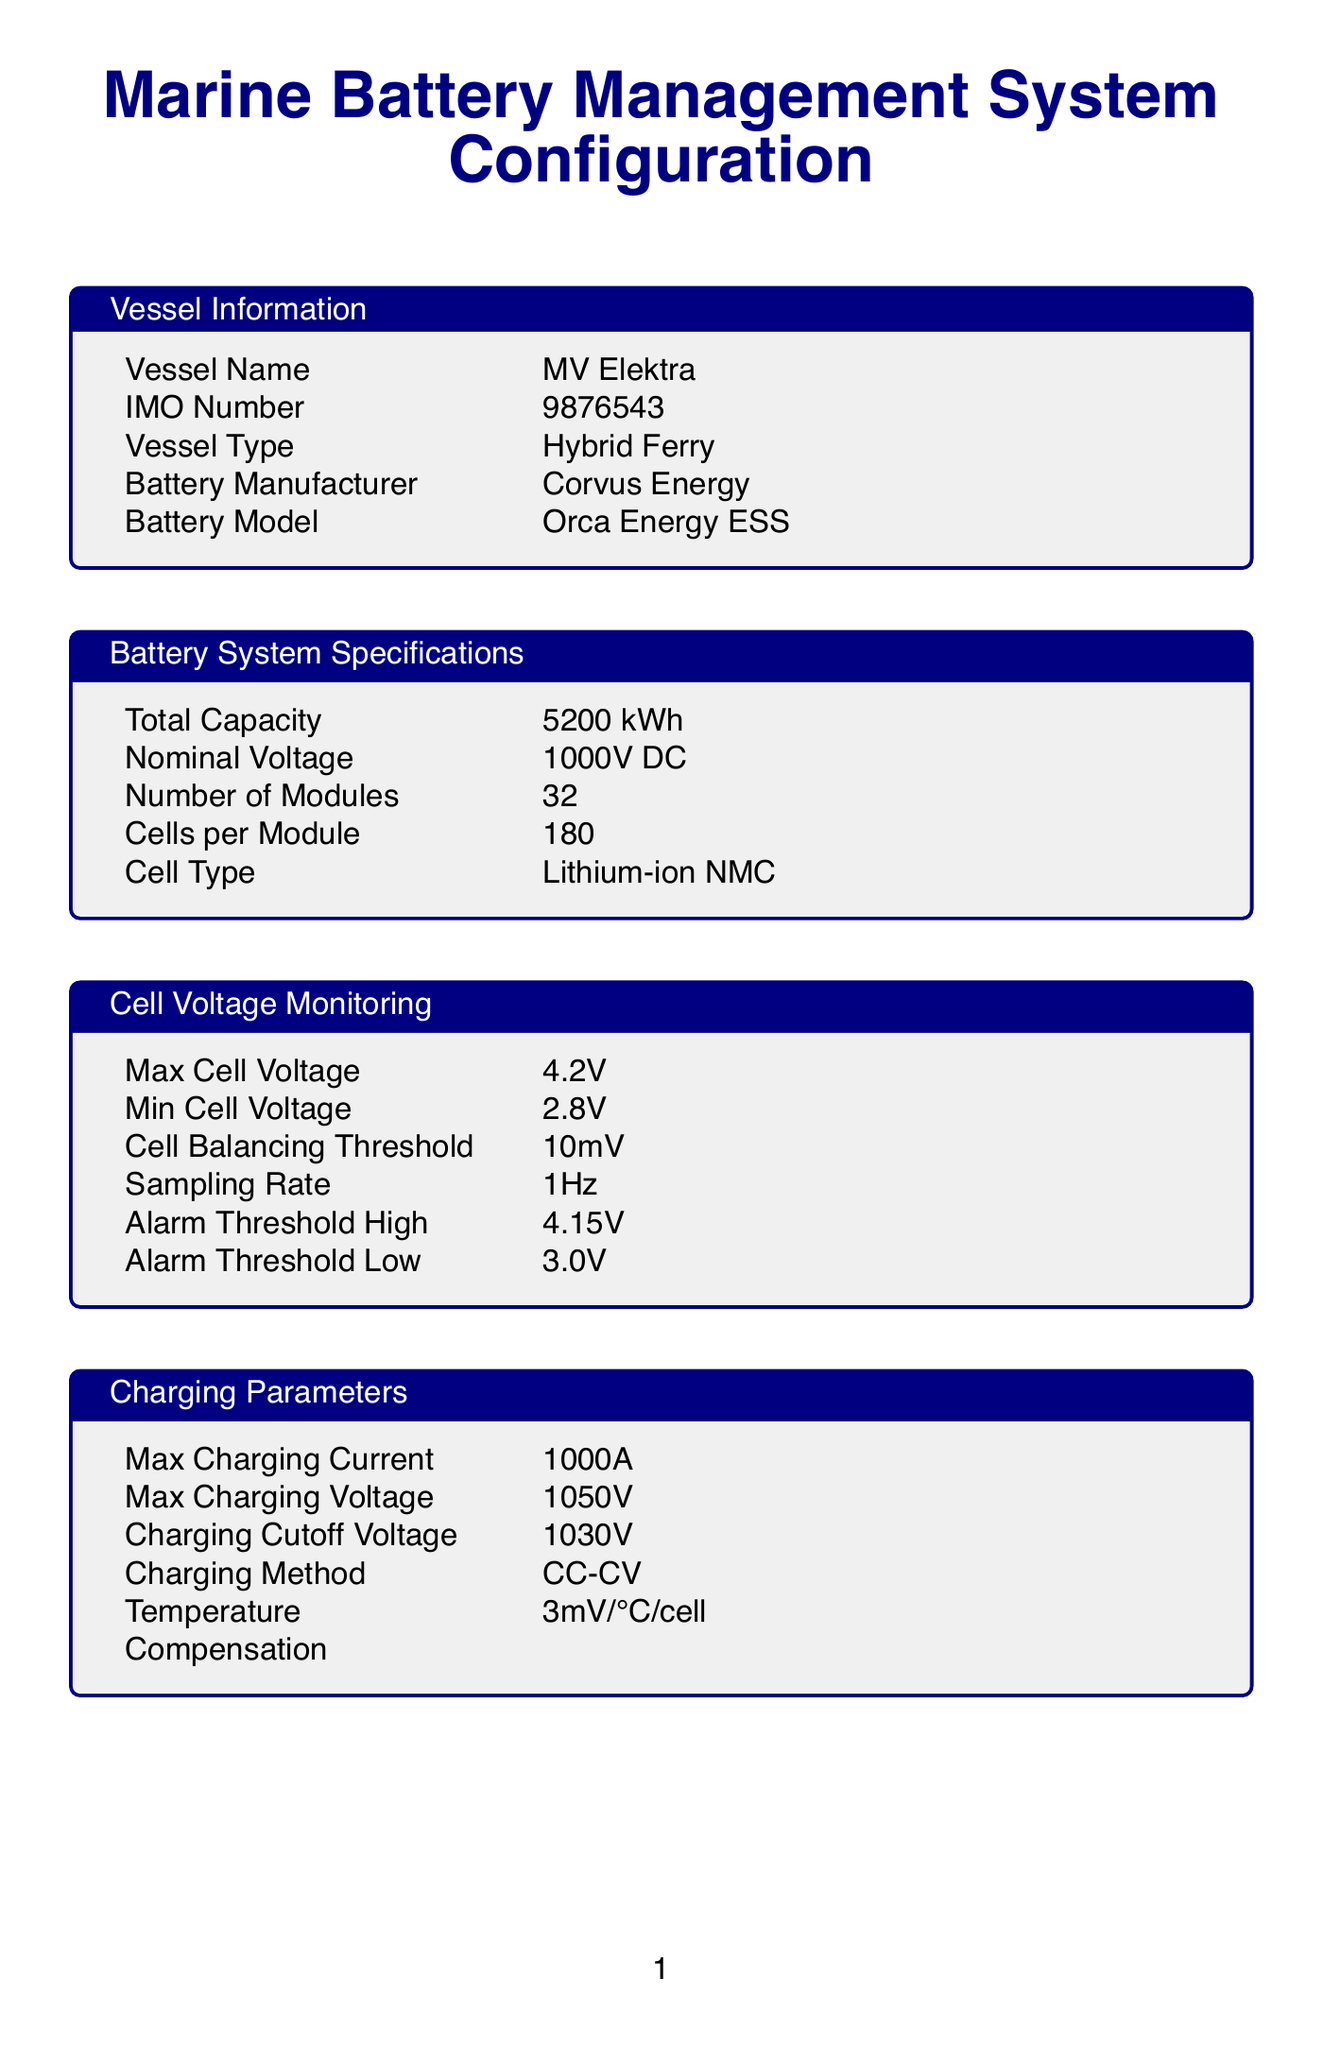what is the vessel name? The vessel name is explicitly stated in the document under Vessel Information.
Answer: MV Elektra what is the nominal voltage of the battery system? The nominal voltage is mentioned in the Battery System Specifications section.
Answer: 1000V DC what is the maximum charging current? The maximum charging current is detailed in the Charging Parameters section of the document.
Answer: 1000A what is the maximum cell voltage? The maximum cell voltage is specified in the Cell Voltage Monitoring section.
Answer: 4.2V what is the classification society for the battery system? The classification society is indicated in the Classification and Compliance section.
Answer: DNV GL how many cells are in total for the battery system? The total number of cells is derived from the number of modules and cells per module in the Battery System Specifications.
Answer: 5760 what is the cooling system used? The cooling system is described in the Thermal Management section of the document.
Answer: Liquid-cooled what is the protocol for engine interface? The engine interface protocol is stated in the Integration with Ship Systems section.
Answer: Modbus TCP/IP what is the charging cutoff voltage? The charging cutoff voltage is mentioned in the Charging Parameters section of the document.
Answer: 1030V 